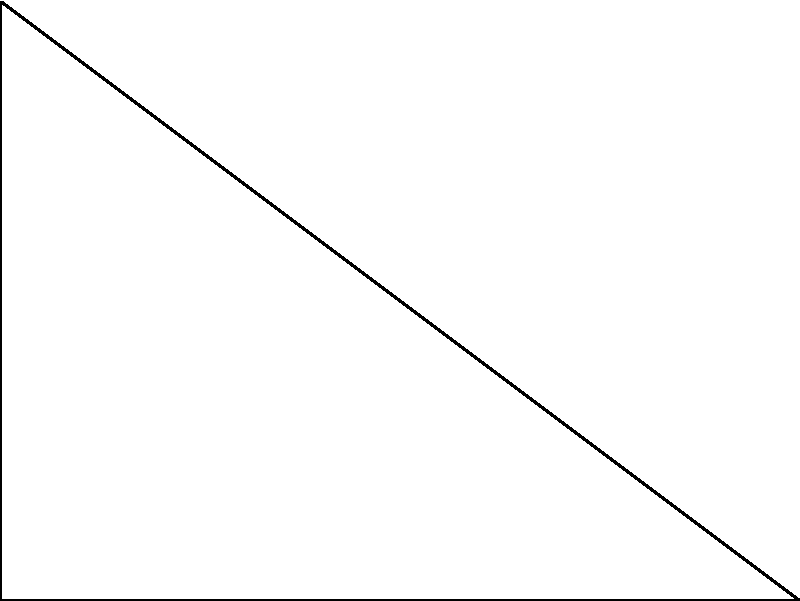Given a right-angled triangle ABC with sides of length 3, 4, and 5 units, determine the radius of the inscribed circle. Express your answer in terms of the area (A) and semi-perimeter (s) of the triangle. To solve this problem, we'll follow these steps:

1) First, recall the formula for the radius (r) of an inscribed circle in terms of the triangle's area (A) and semi-perimeter (s):

   $$r = \frac{A}{s}$$

2) Calculate the semi-perimeter (s):
   $$s = \frac{a + b + c}{2} = \frac{3 + 4 + 5}{2} = 6$$

3) Calculate the area (A) using Heron's formula:
   $$A = \sqrt{s(s-a)(s-b)(s-c)}$$
   $$A = \sqrt{6(6-3)(6-4)(6-5)} = \sqrt{6 \cdot 3 \cdot 2 \cdot 1} = \sqrt{36} = 6$$

4) Now, substitute these values into the radius formula:
   $$r = \frac{A}{s} = \frac{6}{6} = 1$$

5) Therefore, the radius of the inscribed circle is 1 unit.

6) To express this in terms of A and s, we can simply write:
   $$r = \frac{A}{s}$$

This formula is general and applies to all triangles, not just this specific right-angled triangle.
Answer: $r = \frac{A}{s}$ 